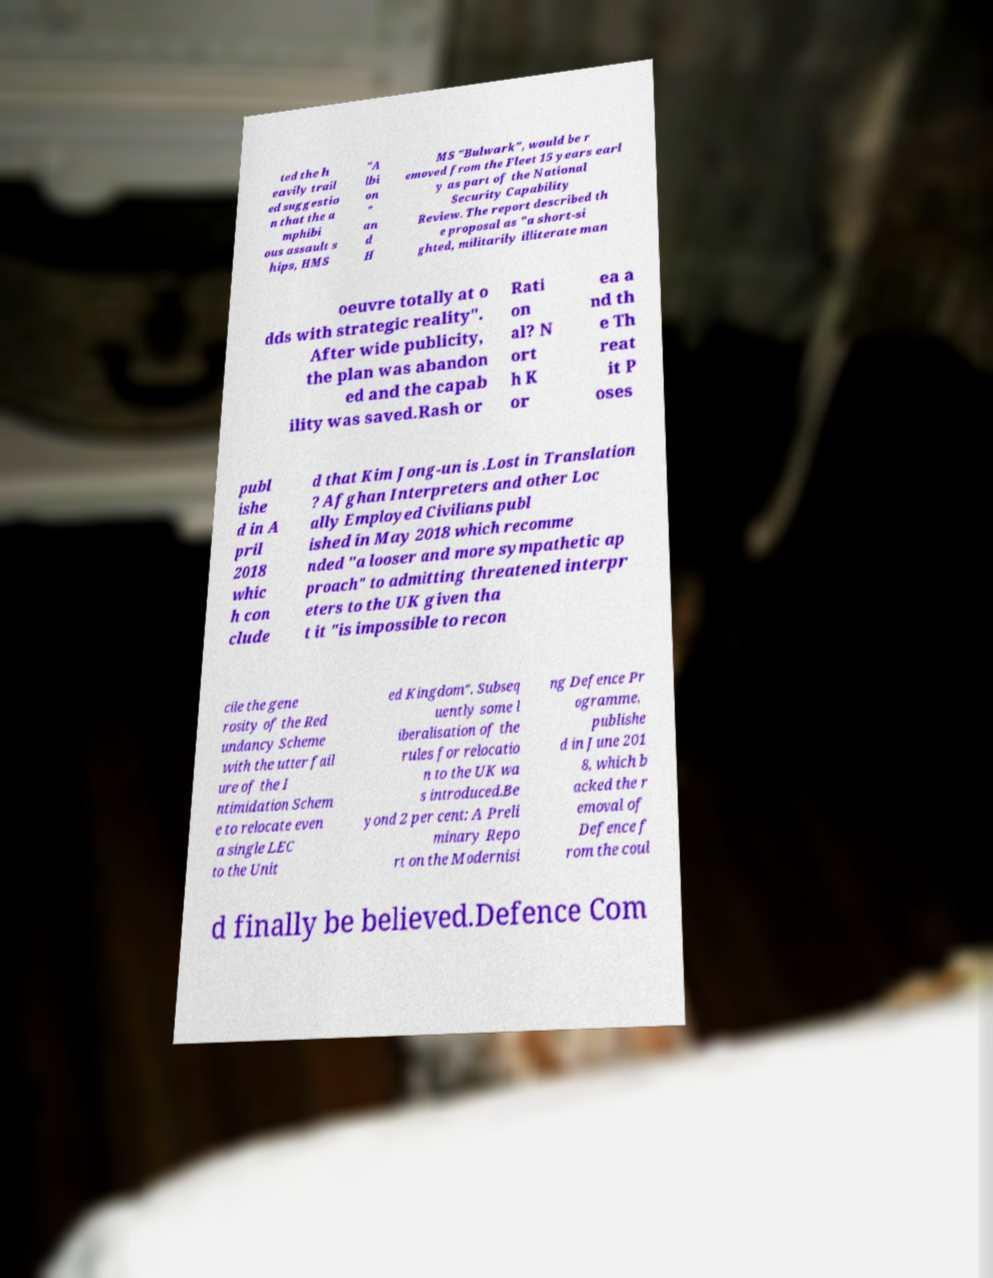Could you extract and type out the text from this image? ted the h eavily trail ed suggestio n that the a mphibi ous assault s hips, HMS "A lbi on " an d H MS "Bulwark", would be r emoved from the Fleet 15 years earl y as part of the National Security Capability Review. The report described th e proposal as "a short-si ghted, militarily illiterate man oeuvre totally at o dds with strategic reality". After wide publicity, the plan was abandon ed and the capab ility was saved.Rash or Rati on al? N ort h K or ea a nd th e Th reat it P oses publ ishe d in A pril 2018 whic h con clude d that Kim Jong-un is .Lost in Translation ? Afghan Interpreters and other Loc ally Employed Civilians publ ished in May 2018 which recomme nded "a looser and more sympathetic ap proach" to admitting threatened interpr eters to the UK given tha t it "is impossible to recon cile the gene rosity of the Red undancy Scheme with the utter fail ure of the I ntimidation Schem e to relocate even a single LEC to the Unit ed Kingdom". Subseq uently some l iberalisation of the rules for relocatio n to the UK wa s introduced.Be yond 2 per cent: A Preli minary Repo rt on the Modernisi ng Defence Pr ogramme, publishe d in June 201 8, which b acked the r emoval of Defence f rom the coul d finally be believed.Defence Com 